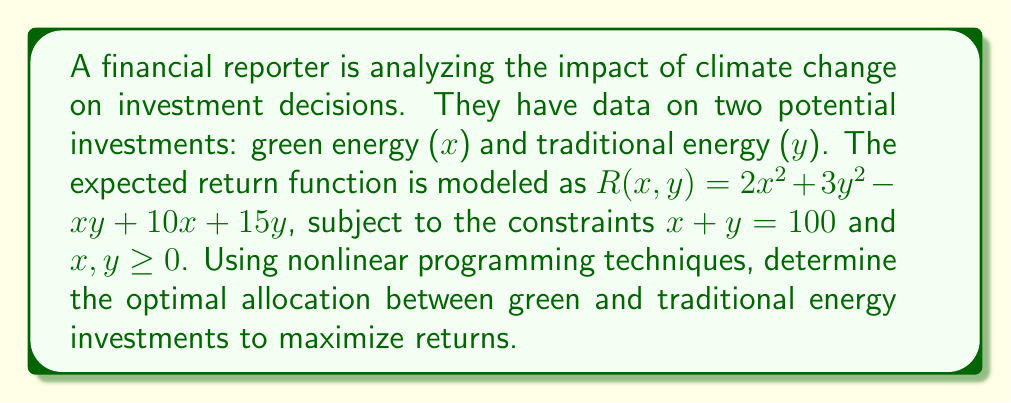Can you answer this question? 1. Set up the optimization problem:
   Maximize $R(x,y) = 2x^2 + 3y^2 - xy + 10x + 15y$
   Subject to: $x + y = 100$ and $x, y \geq 0$

2. Use the constraint $x + y = 100$ to eliminate $y$:
   $y = 100 - x$
   Substitute this into the objective function:
   $R(x) = 2x^2 + 3(100-x)^2 - x(100-x) + 10x + 15(100-x)$

3. Expand the function:
   $R(x) = 2x^2 + 30000 - 600x + 3x^2 - 100x + x^2 + 10x + 1500 - 15x$
   $R(x) = 6x^2 - 705x + 31500$

4. To find the maximum, take the derivative and set it to zero:
   $\frac{dR}{dx} = 12x - 705 = 0$

5. Solve for x:
   $12x = 705$
   $x = 58.75$

6. Calculate y:
   $y = 100 - x = 100 - 58.75 = 41.25$

7. Verify that this solution satisfies the non-negativity constraints:
   $x = 58.75 \geq 0$ and $y = 41.25 \geq 0$

8. Check the second derivative to confirm it's a maximum:
   $\frac{d^2R}{dx^2} = 12 > 0$, confirming a local minimum for $-R(x)$, thus a local maximum for $R(x)$

Therefore, the optimal allocation is approximately 58.75 units in green energy and 41.25 units in traditional energy.
Answer: Green energy: 58.75 units; Traditional energy: 41.25 units 